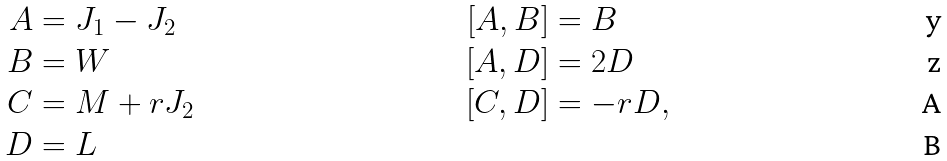<formula> <loc_0><loc_0><loc_500><loc_500>A & = J _ { 1 } - J _ { 2 } & [ A , B ] & = B \\ B & = W & [ A , D ] & = 2 D \\ C & = M + r J _ { 2 } & [ C , D ] & = - r D , \\ D & = L</formula> 